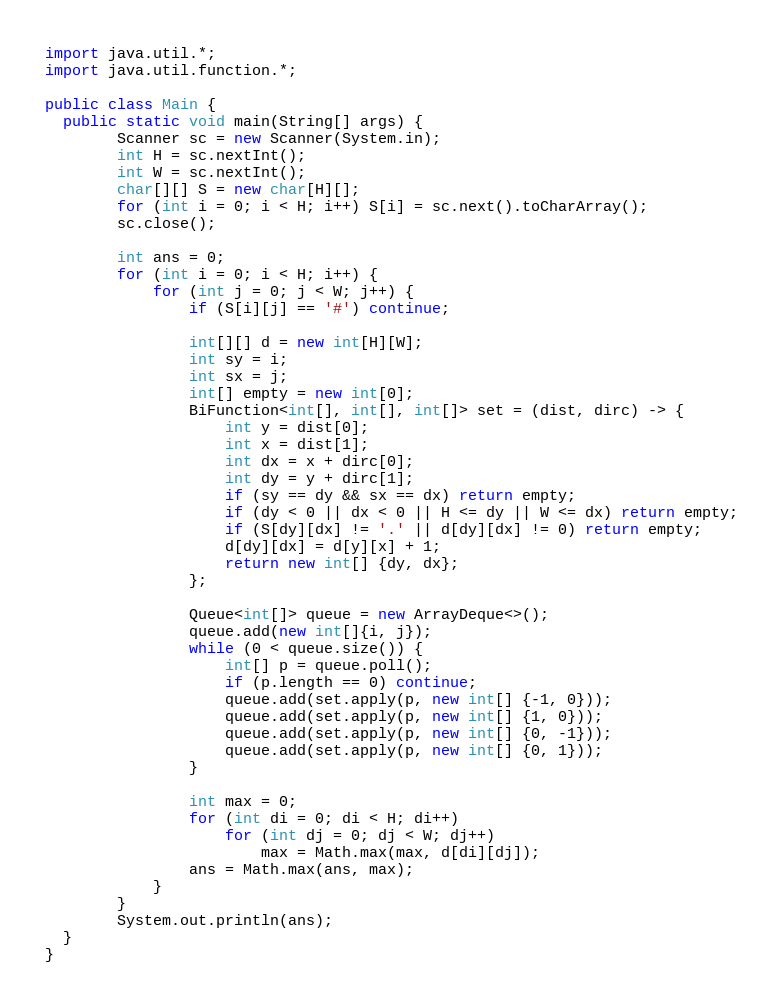Convert code to text. <code><loc_0><loc_0><loc_500><loc_500><_Java_>import java.util.*;
import java.util.function.*;
 
public class Main {
  public static void main(String[] args) {
		Scanner sc = new Scanner(System.in);
		int H = sc.nextInt();
		int W = sc.nextInt();
		char[][] S = new char[H][];
		for (int i = 0; i < H; i++) S[i] = sc.next().toCharArray();
		sc.close();

		int ans = 0;
		for (int i = 0; i < H; i++) {
			for (int j = 0; j < W; j++) {
				if (S[i][j] == '#') continue;

				int[][] d = new int[H][W];
				int sy = i;
				int sx = j;
				int[] empty = new int[0];
				BiFunction<int[], int[], int[]> set = (dist, dirc) -> {
					int y = dist[0];
					int x = dist[1];
					int dx = x + dirc[0];
					int dy = y + dirc[1];
					if (sy == dy && sx == dx) return empty;
					if (dy < 0 || dx < 0 || H <= dy || W <= dx) return empty;
					if (S[dy][dx] != '.' || d[dy][dx] != 0) return empty;
					d[dy][dx] = d[y][x] + 1;
					return new int[] {dy, dx};
				};

				Queue<int[]> queue = new ArrayDeque<>();
				queue.add(new int[]{i, j});
				while (0 < queue.size()) {
					int[] p = queue.poll();
					if (p.length == 0) continue;
					queue.add(set.apply(p, new int[] {-1, 0}));
					queue.add(set.apply(p, new int[] {1, 0}));
					queue.add(set.apply(p, new int[] {0, -1}));
					queue.add(set.apply(p, new int[] {0, 1}));
				}

				int max = 0;
				for (int di = 0; di < H; di++)
					for (int dj = 0; dj < W; dj++)
						max = Math.max(max, d[di][dj]);
				ans = Math.max(ans, max);
			}
		}
		System.out.println(ans);
  }
}</code> 